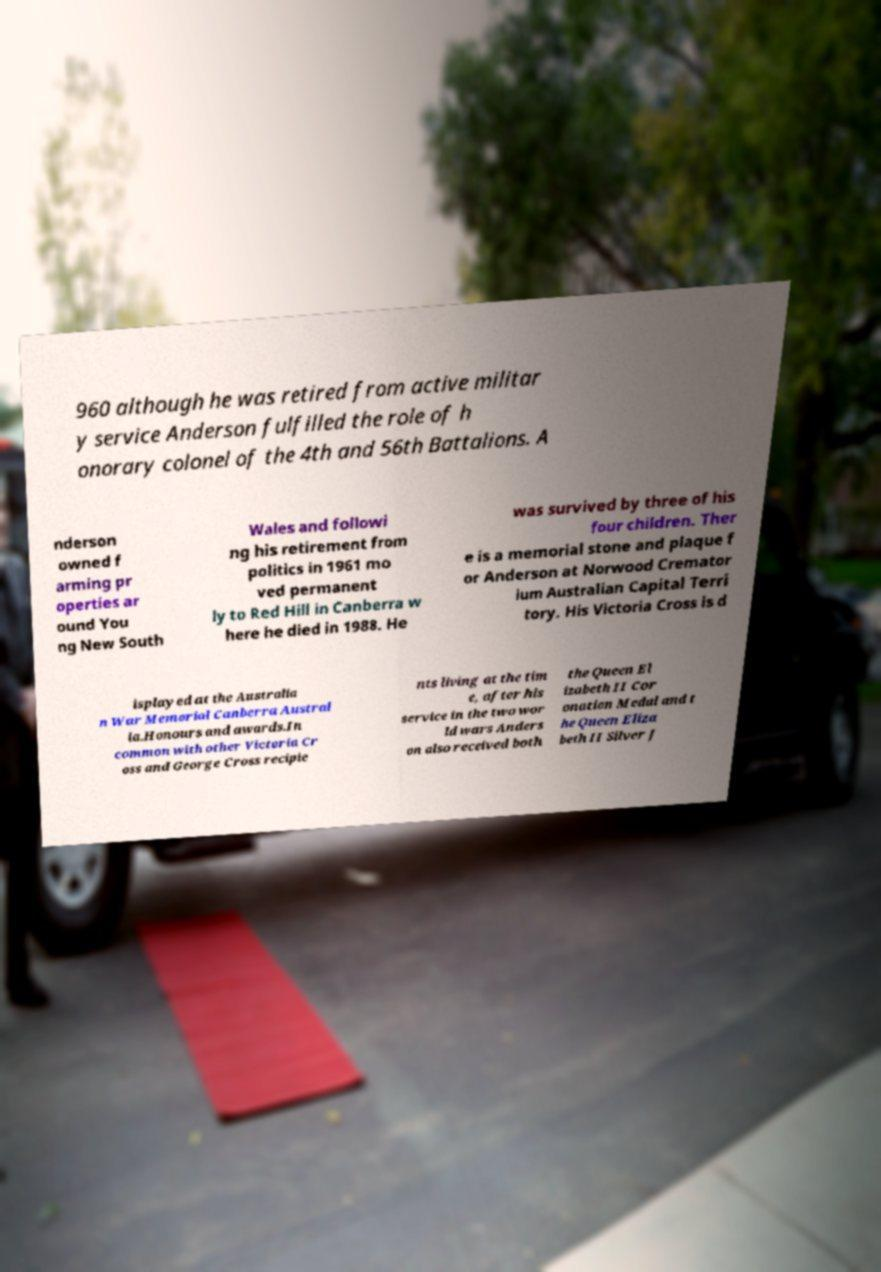Please read and relay the text visible in this image. What does it say? 960 although he was retired from active militar y service Anderson fulfilled the role of h onorary colonel of the 4th and 56th Battalions. A nderson owned f arming pr operties ar ound You ng New South Wales and followi ng his retirement from politics in 1961 mo ved permanent ly to Red Hill in Canberra w here he died in 1988. He was survived by three of his four children. Ther e is a memorial stone and plaque f or Anderson at Norwood Cremator ium Australian Capital Terri tory. His Victoria Cross is d isplayed at the Australia n War Memorial Canberra Austral ia.Honours and awards.In common with other Victoria Cr oss and George Cross recipie nts living at the tim e, after his service in the two wor ld wars Anders on also received both the Queen El izabeth II Cor onation Medal and t he Queen Eliza beth II Silver J 